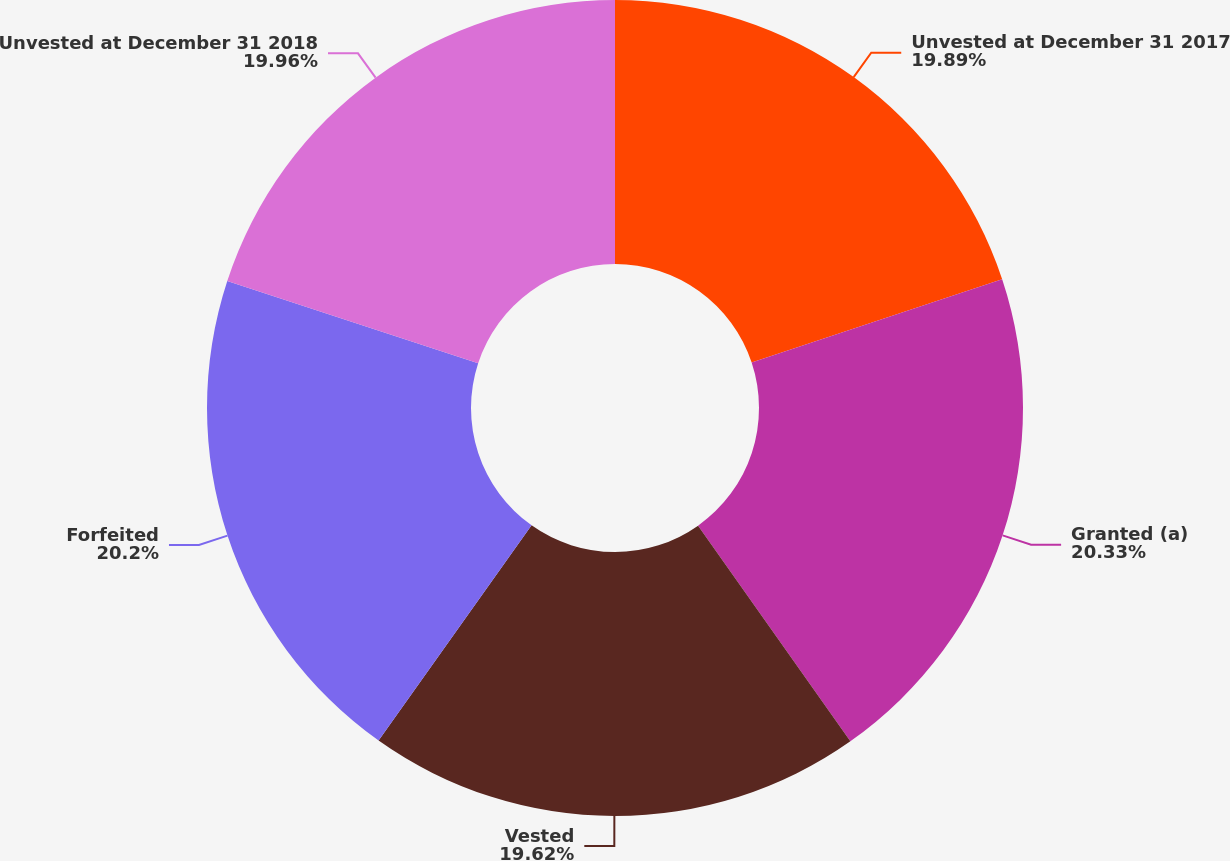Convert chart. <chart><loc_0><loc_0><loc_500><loc_500><pie_chart><fcel>Unvested at December 31 2017<fcel>Granted (a)<fcel>Vested<fcel>Forfeited<fcel>Unvested at December 31 2018<nl><fcel>19.89%<fcel>20.32%<fcel>19.62%<fcel>20.2%<fcel>19.96%<nl></chart> 